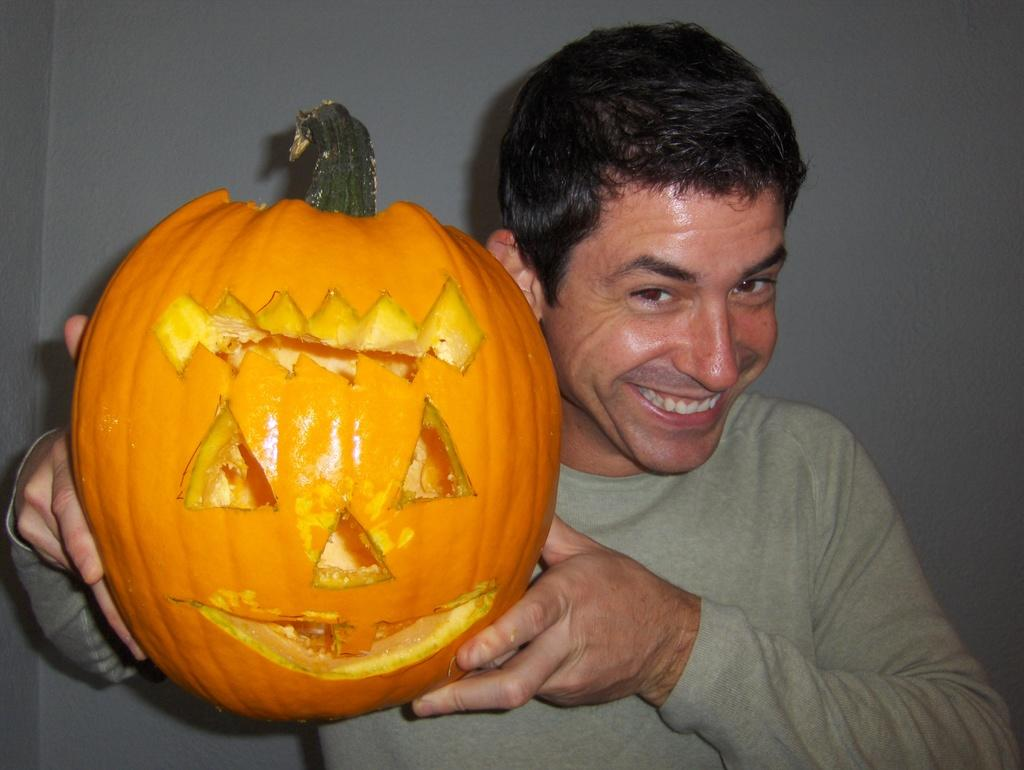Who is present in the image? There is a man in the image. What is the man holding in the image? The man is holding a pumpkin. Can you describe the pumpkin in the image? The pumpkin is carved in the shape of a Halloween pumpkin. What health benefits does the pumpkin provide in the image? The image does not provide information about the health benefits of the pumpkin. 